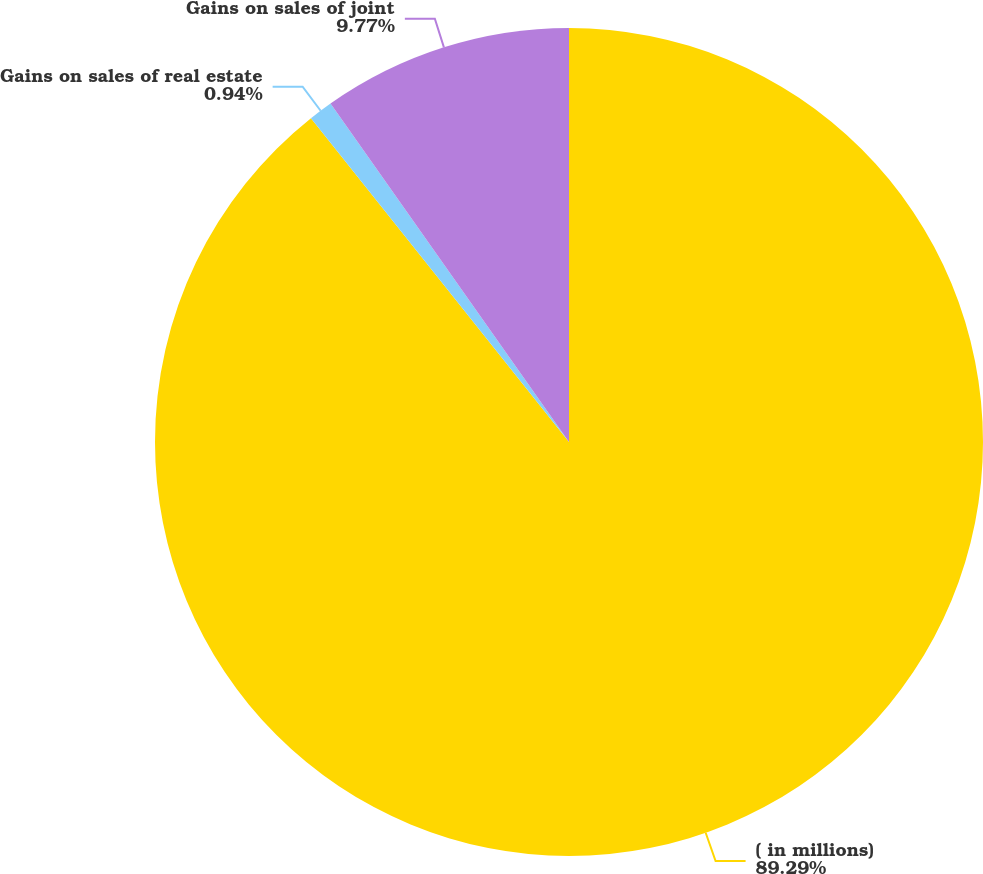<chart> <loc_0><loc_0><loc_500><loc_500><pie_chart><fcel>( in millions)<fcel>Gains on sales of real estate<fcel>Gains on sales of joint<nl><fcel>89.29%<fcel>0.94%<fcel>9.77%<nl></chart> 